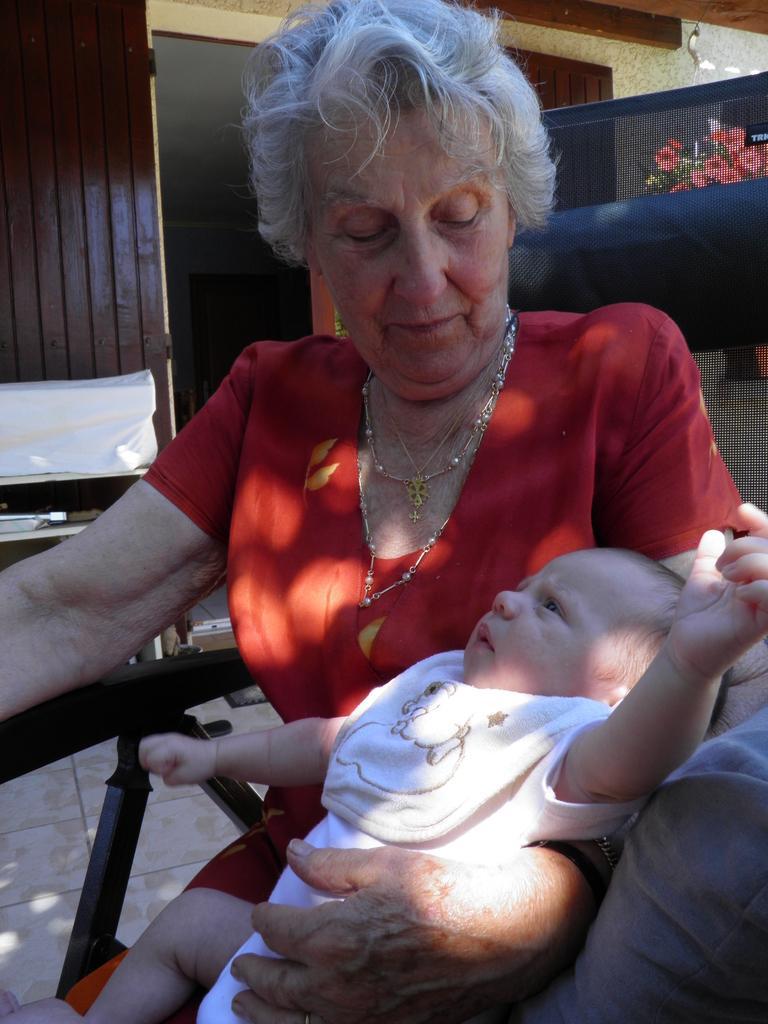Could you give a brief overview of what you see in this image? In this picture I can see a woman seated and she is holding a baby in her hand and I can see plant with flowers and looks like a door in the back. 